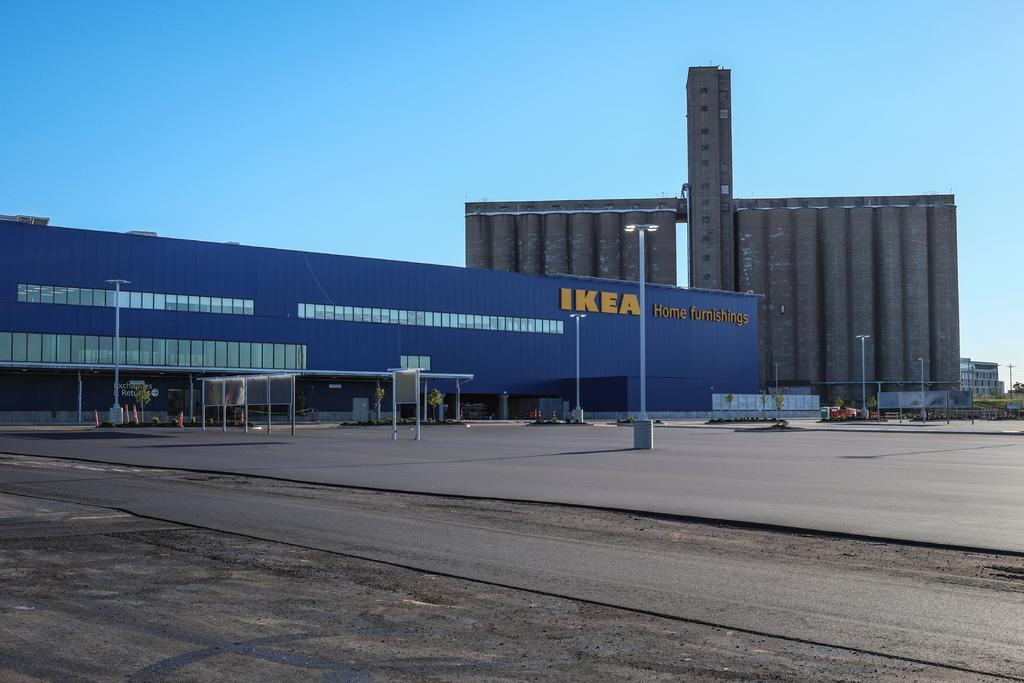Please provide a concise description of this image. In this picture we can see the ground, poles, trees, buildings and some objects and in the background we can see the sky. 